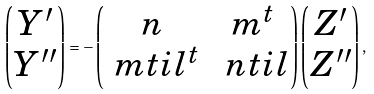Convert formula to latex. <formula><loc_0><loc_0><loc_500><loc_500>\begin{pmatrix} Y ^ { \prime } \\ Y ^ { \prime \prime } \end{pmatrix} = - \begin{pmatrix} n & m ^ { t } \\ \ m t i l ^ { t } & \ n t i l \end{pmatrix} \begin{pmatrix} Z ^ { \prime } \\ Z ^ { \prime \prime } \end{pmatrix} ,</formula> 